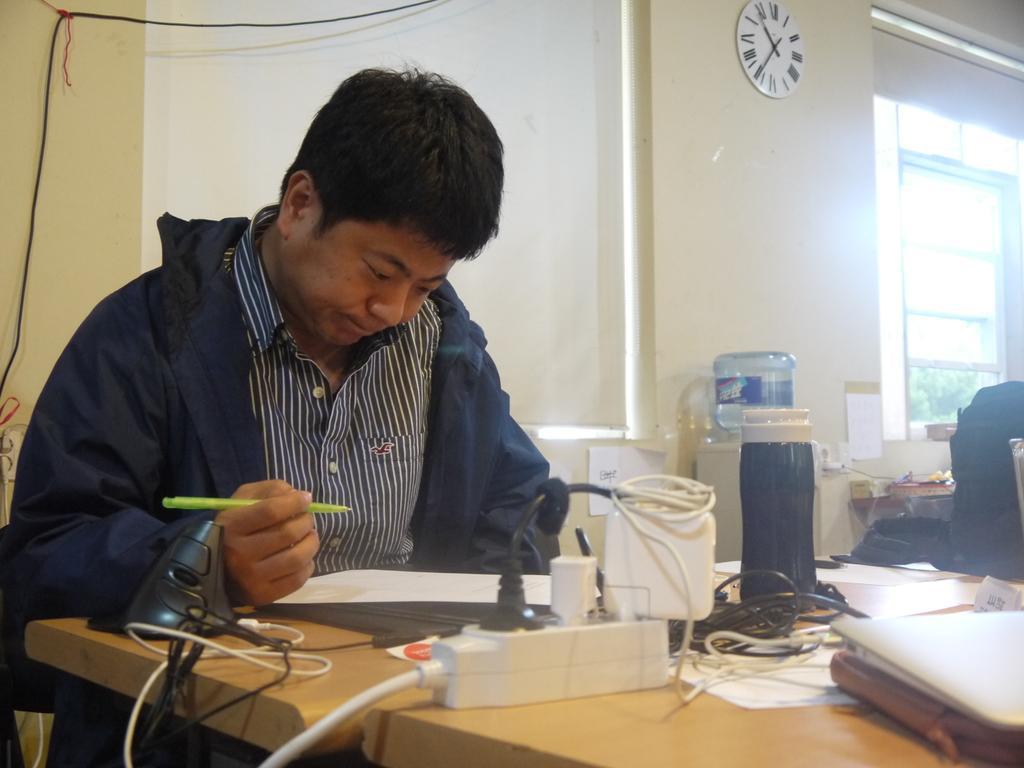Can you describe this image briefly? this picture shows a man seated and writing with the pen and we see some papers, laptop and books on the table and we see a water in a water bottle and a wall clock on the wall 